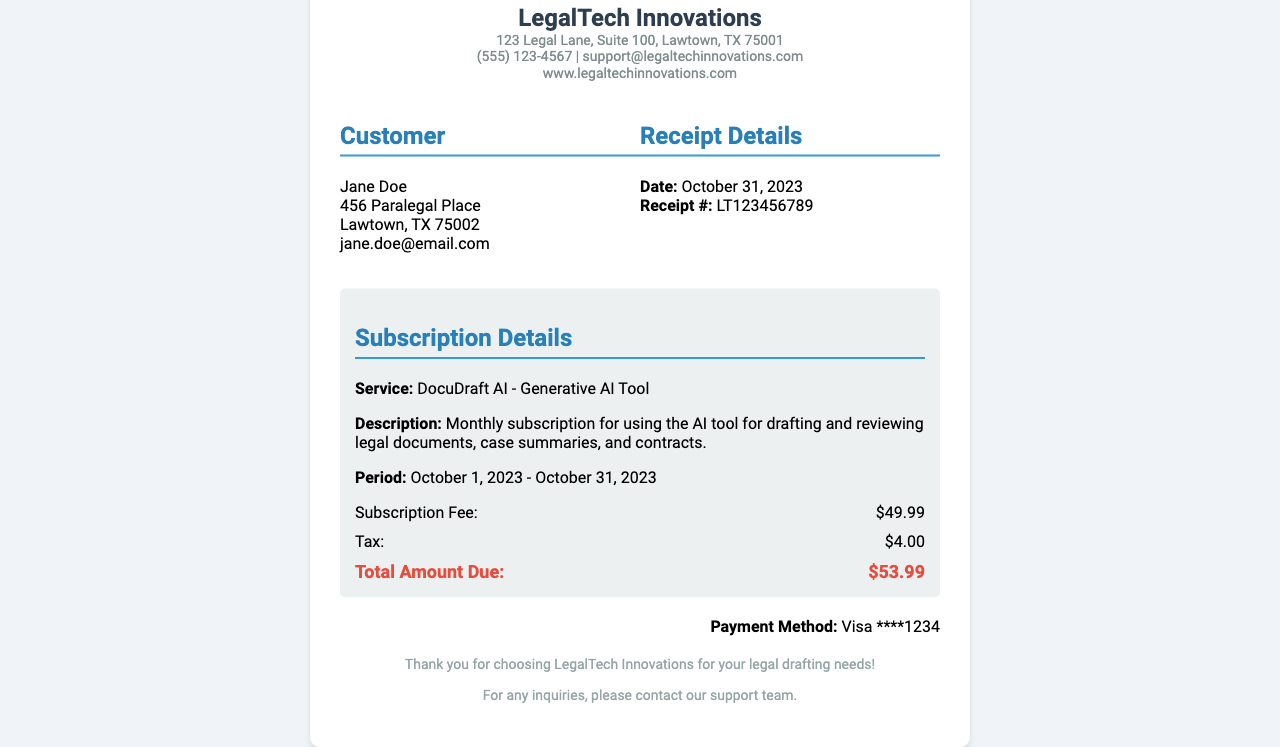What is the service name? The service name is provided in the subscription details section of the document.
Answer: DocuDraft AI - Generative AI Tool What is the total amount due? The total amount due is mentioned at the end of the subscription details.
Answer: $53.99 What is the period of the subscription? The period of the subscription specifies the start and end dates for the service.
Answer: October 1, 2023 - October 31, 2023 Who is the customer? The customer’s name is listed at the top of the customer information section.
Answer: Jane Doe What is the tax amount? The tax amount is included within the subscription details.
Answer: $4.00 When was the receipt issued? The date of the receipt is clearly stated in the receipt details section.
Answer: October 31, 2023 What is the payment method? The payment method is provided in the payment method section of the document.
Answer: Visa ****1234 What is the description of the service? The description gives details about what the service entails.
Answer: Monthly subscription for using the AI tool for drafting and reviewing legal documents, case summaries, and contracts What is the receipt number? The receipt number is listed in the receipt details section.
Answer: LT123456789 